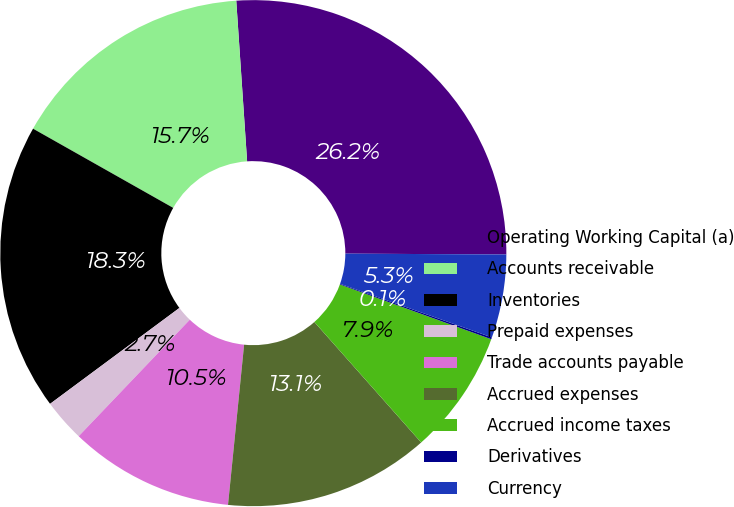<chart> <loc_0><loc_0><loc_500><loc_500><pie_chart><fcel>Operating Working Capital (a)<fcel>Accounts receivable<fcel>Inventories<fcel>Prepaid expenses<fcel>Trade accounts payable<fcel>Accrued expenses<fcel>Accrued income taxes<fcel>Derivatives<fcel>Currency<nl><fcel>26.16%<fcel>15.74%<fcel>18.34%<fcel>2.72%<fcel>10.53%<fcel>13.14%<fcel>7.93%<fcel>0.12%<fcel>5.32%<nl></chart> 